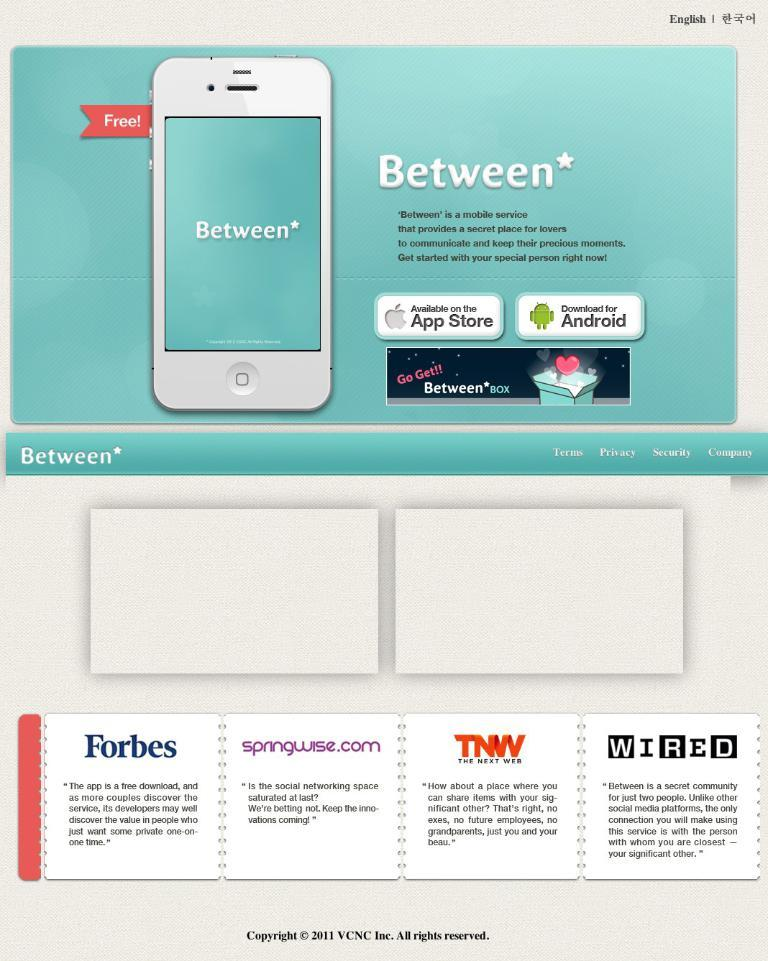What is featured on the poster in the image? The poster contains a picture of an iPhone. What else can be seen on the poster besides the iPhone? There is text on the poster. What type of comb is shown in the image? There is no comb present in the image. Is there eggnog being served in the image? There is no eggnog visible in the image. 